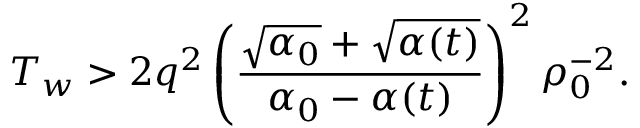Convert formula to latex. <formula><loc_0><loc_0><loc_500><loc_500>T _ { w } > 2 q ^ { 2 } \left ( \frac { \sqrt { \alpha _ { 0 } } + \sqrt { \alpha ( t ) } } { \alpha _ { 0 } - \alpha ( t ) } \right ) ^ { 2 } \rho _ { 0 } ^ { - 2 } .</formula> 